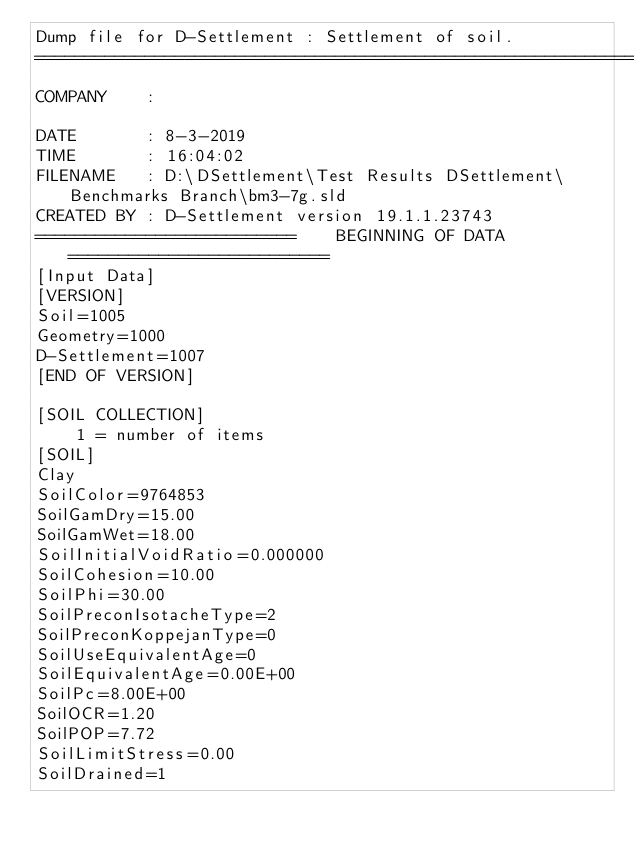Convert code to text. <code><loc_0><loc_0><loc_500><loc_500><_Scheme_>Dump file for D-Settlement : Settlement of soil.
==============================================================================
COMPANY    : 

DATE       : 8-3-2019
TIME       : 16:04:02
FILENAME   : D:\DSettlement\Test Results DSettlement\Benchmarks Branch\bm3-7g.sld
CREATED BY : D-Settlement version 19.1.1.23743
==========================    BEGINNING OF DATA     ==========================
[Input Data]
[VERSION]
Soil=1005
Geometry=1000
D-Settlement=1007
[END OF VERSION]

[SOIL COLLECTION]
    1 = number of items
[SOIL]
Clay
SoilColor=9764853
SoilGamDry=15.00
SoilGamWet=18.00
SoilInitialVoidRatio=0.000000
SoilCohesion=10.00
SoilPhi=30.00
SoilPreconIsotacheType=2
SoilPreconKoppejanType=0
SoilUseEquivalentAge=0
SoilEquivalentAge=0.00E+00
SoilPc=8.00E+00
SoilOCR=1.20
SoilPOP=7.72
SoilLimitStress=0.00
SoilDrained=1</code> 